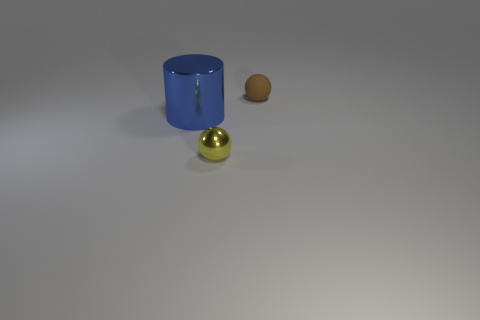Add 1 large green shiny objects. How many objects exist? 4 Subtract all spheres. How many objects are left? 1 Subtract all metal cylinders. Subtract all tiny yellow things. How many objects are left? 1 Add 2 tiny objects. How many tiny objects are left? 4 Add 2 tiny yellow shiny things. How many tiny yellow shiny things exist? 3 Subtract 0 gray spheres. How many objects are left? 3 